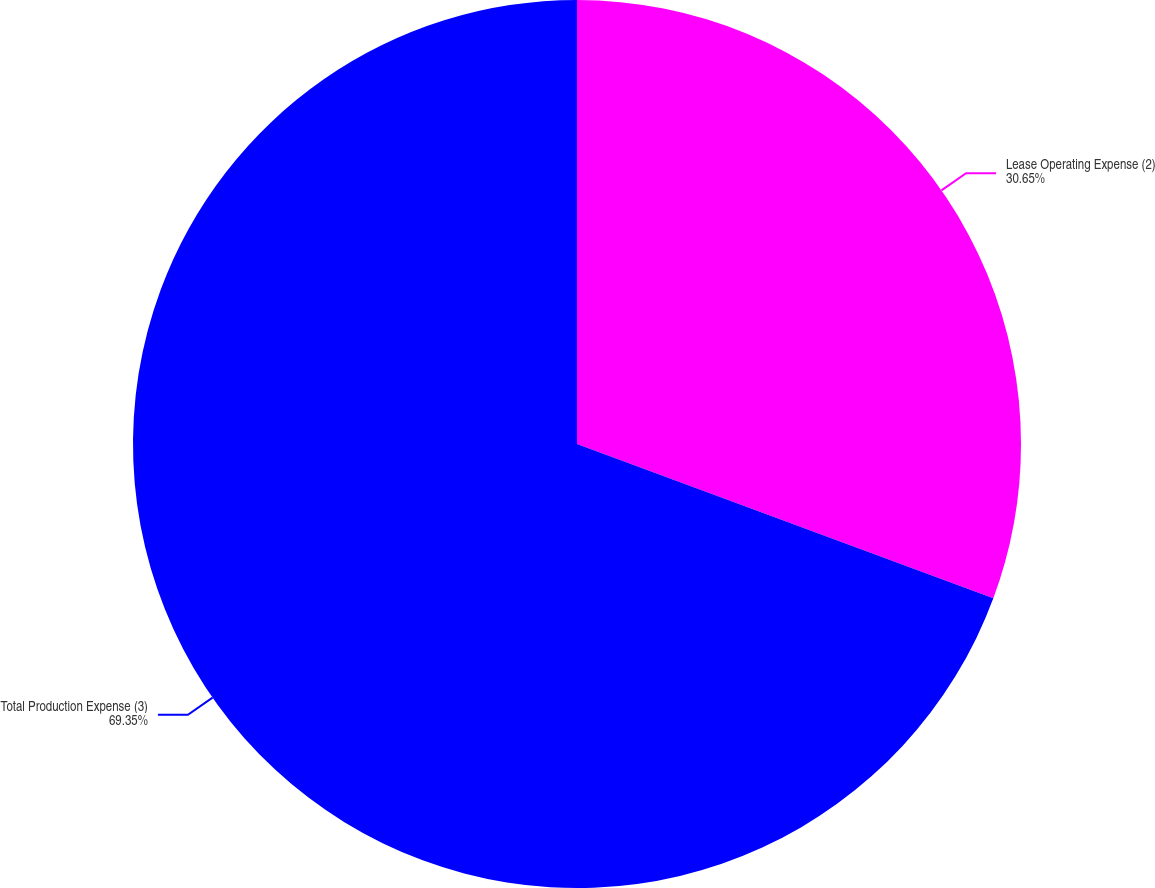Convert chart to OTSL. <chart><loc_0><loc_0><loc_500><loc_500><pie_chart><fcel>Lease Operating Expense (2)<fcel>Total Production Expense (3)<nl><fcel>30.65%<fcel>69.35%<nl></chart> 